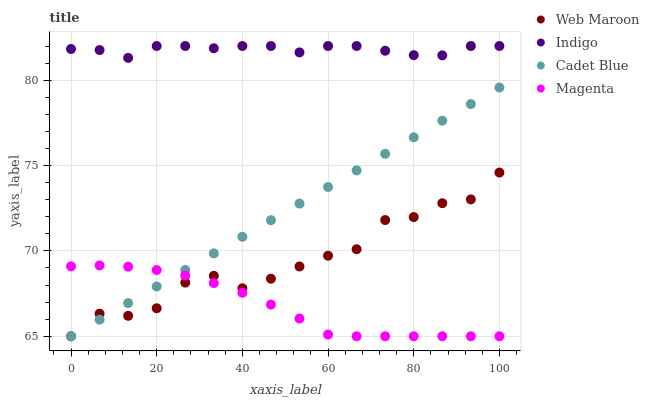Does Magenta have the minimum area under the curve?
Answer yes or no. Yes. Does Indigo have the maximum area under the curve?
Answer yes or no. Yes. Does Cadet Blue have the minimum area under the curve?
Answer yes or no. No. Does Cadet Blue have the maximum area under the curve?
Answer yes or no. No. Is Cadet Blue the smoothest?
Answer yes or no. Yes. Is Web Maroon the roughest?
Answer yes or no. Yes. Is Magenta the smoothest?
Answer yes or no. No. Is Magenta the roughest?
Answer yes or no. No. Does Magenta have the lowest value?
Answer yes or no. Yes. Does Indigo have the highest value?
Answer yes or no. Yes. Does Cadet Blue have the highest value?
Answer yes or no. No. Is Cadet Blue less than Indigo?
Answer yes or no. Yes. Is Indigo greater than Cadet Blue?
Answer yes or no. Yes. Does Magenta intersect Web Maroon?
Answer yes or no. Yes. Is Magenta less than Web Maroon?
Answer yes or no. No. Is Magenta greater than Web Maroon?
Answer yes or no. No. Does Cadet Blue intersect Indigo?
Answer yes or no. No. 